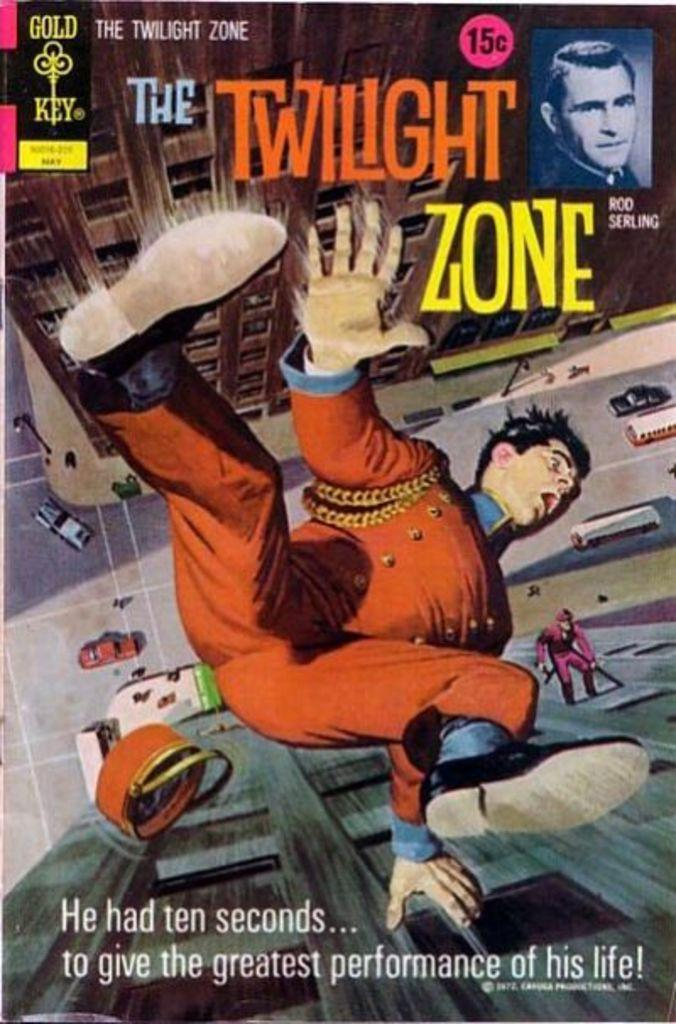What is featured on the poster in the image? The poster contains cartoon images and images of buildings. What type of images are depicted on the poster? The images on the poster are cartoon images and images of buildings. Is there any text present on the poster? Yes, there is text present on the poster. What hobbies are the cartoon characters on the poster engaged in? There is no information about the hobbies of the cartoon characters on the poster, as the facts provided do not mention any specific activities or hobbies. 